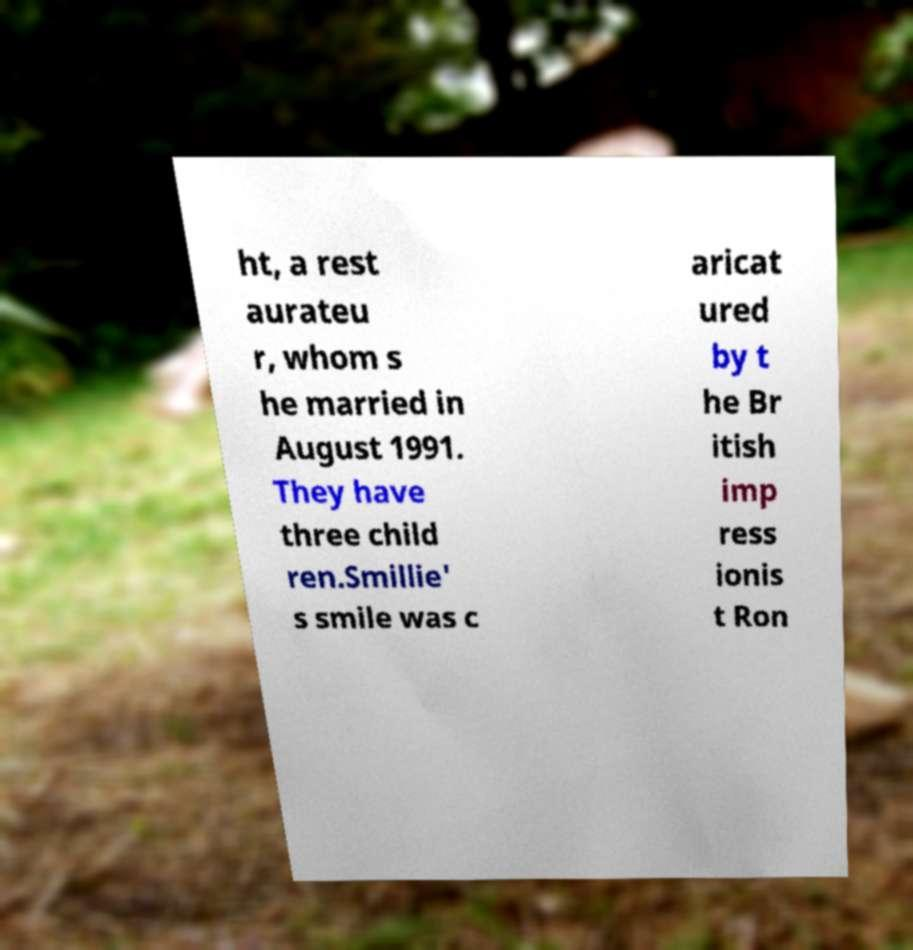Can you read and provide the text displayed in the image?This photo seems to have some interesting text. Can you extract and type it out for me? ht, a rest aurateu r, whom s he married in August 1991. They have three child ren.Smillie' s smile was c aricat ured by t he Br itish imp ress ionis t Ron 